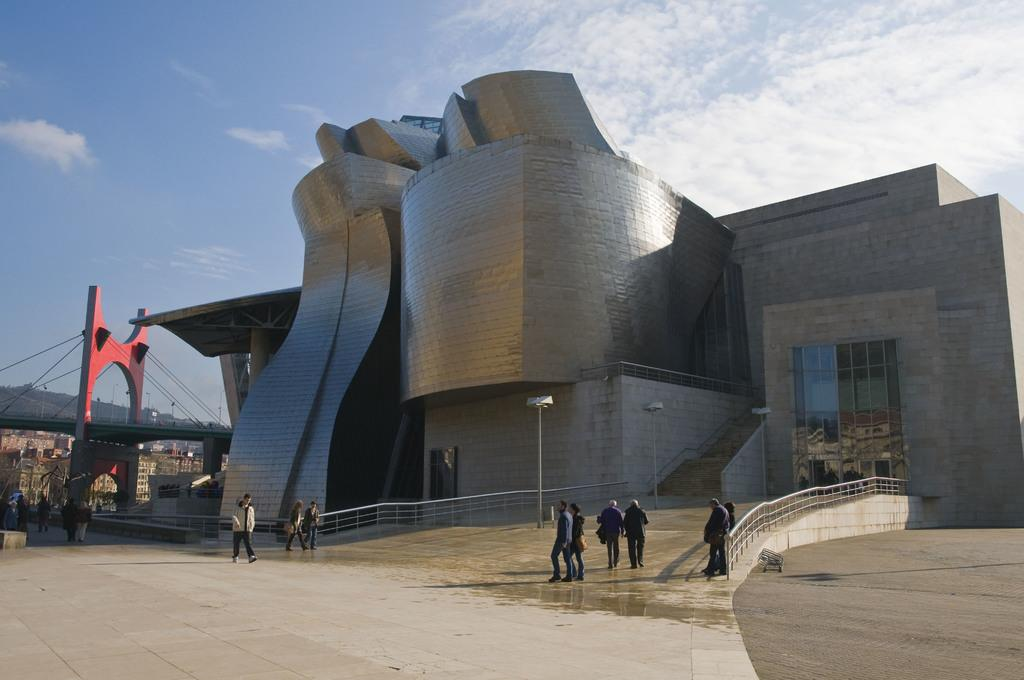What structure is located in the middle of the image? There is a building in the middle of the image. What can be seen on the left side of the image? There is a bridge on the left side of the image. Who or what is visible at the bottom of the image? There are persons visible at the bottom of the image. What is visible at the top of the image? The sky is visible at the top of the image. What type of wing is attached to the engine in the image? There is no wing or engine present in the image. How does the look on the person's face change throughout the image? The provided facts do not mention any facial expressions or changes in appearance for the persons visible in the image. 